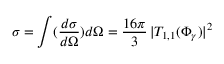<formula> <loc_0><loc_0><loc_500><loc_500>\sigma = \int ( \frac { d \sigma } { d \Omega } ) d \Omega = \frac { 1 6 \pi } { 3 } \, | T _ { 1 , 1 } ( \Phi _ { \gamma } ) | ^ { 2 }</formula> 